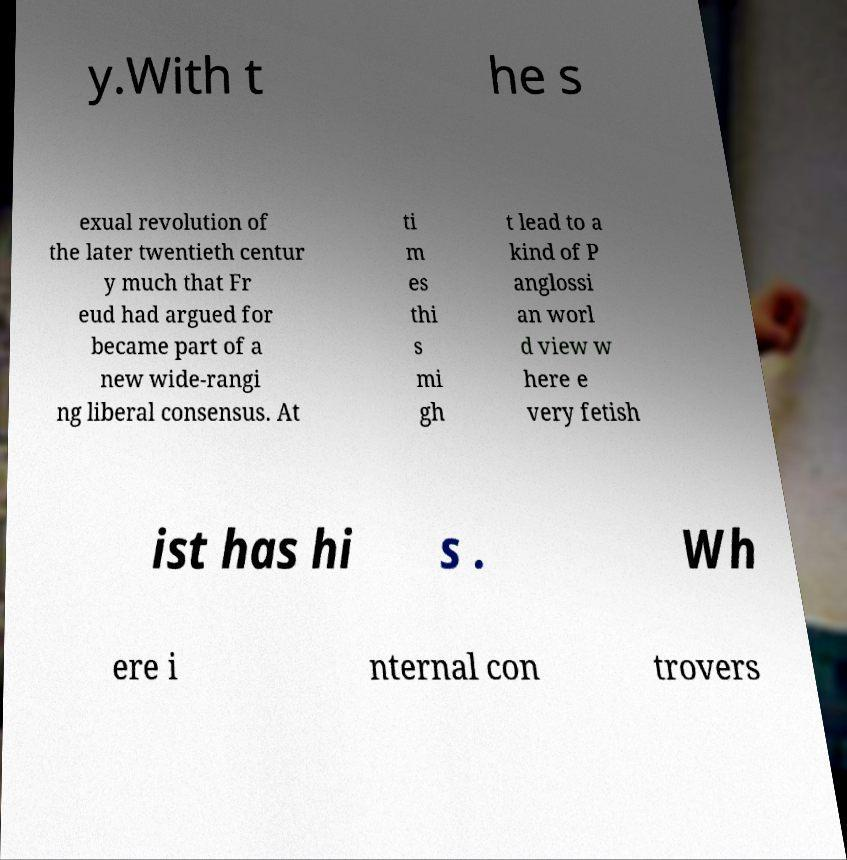Please identify and transcribe the text found in this image. y.With t he s exual revolution of the later twentieth centur y much that Fr eud had argued for became part of a new wide-rangi ng liberal consensus. At ti m es thi s mi gh t lead to a kind of P anglossi an worl d view w here e very fetish ist has hi s . Wh ere i nternal con trovers 